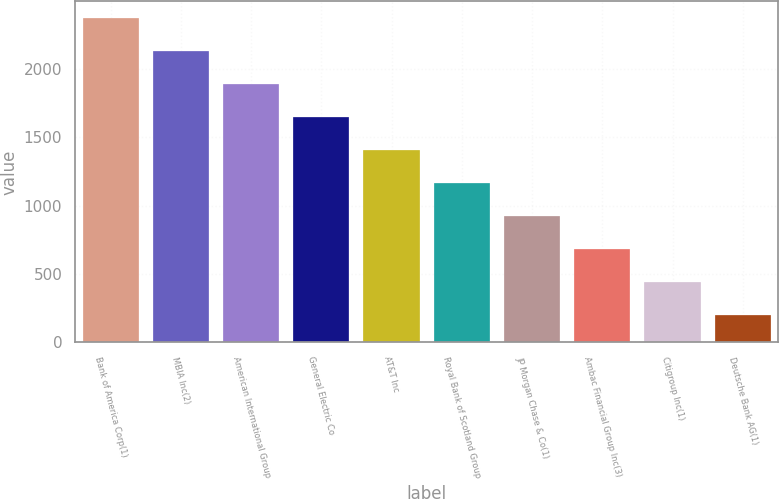Convert chart to OTSL. <chart><loc_0><loc_0><loc_500><loc_500><bar_chart><fcel>Bank of America Corp(1)<fcel>MBIA Inc(2)<fcel>American International Group<fcel>General Electric Co<fcel>AT&T Inc<fcel>Royal Bank of Scotland Group<fcel>JP Morgan Chase & Co(1)<fcel>Ambac Financial Group Inc(3)<fcel>Citigroup Inc(1)<fcel>Deutsche Bank AG(1)<nl><fcel>2374.41<fcel>2133.22<fcel>1892.03<fcel>1650.84<fcel>1409.65<fcel>1168.46<fcel>927.27<fcel>686.08<fcel>444.89<fcel>203.7<nl></chart> 